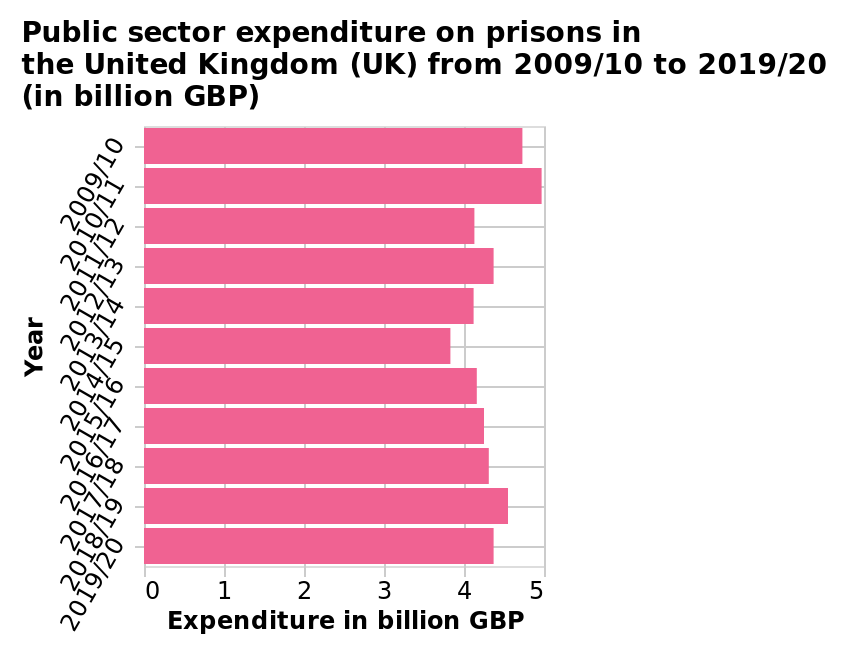<image>
How many years are represented on the bar plot? There are 11 years represented on the bar plot, from 2009/10 to 2019/20. When was the highest expenditure on prisons?  The highest expenditure on prisons was in 2010/11. What is the unit of measurement for the expenditure values on the bar plot? The unit of measurement for the expenditure values on the bar plot is billion GBP. What was the expenditure on prisons in 2018/19?  The expenditure on prisons in 2018/19 was £4.5bn. What was the expenditure on prisons in 2014/15?  The expenditure on prisons in 2014/15 was around £3.8bn. Which year had the lowest expenditure on prisons in the given time series? The lowest year for expenditure in the given time series was 2014/15. 